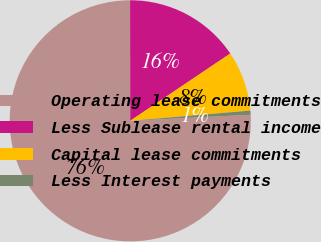Convert chart to OTSL. <chart><loc_0><loc_0><loc_500><loc_500><pie_chart><fcel>Operating lease commitments<fcel>Less Sublease rental income<fcel>Capital lease commitments<fcel>Less Interest payments<nl><fcel>75.78%<fcel>15.6%<fcel>8.07%<fcel>0.55%<nl></chart> 